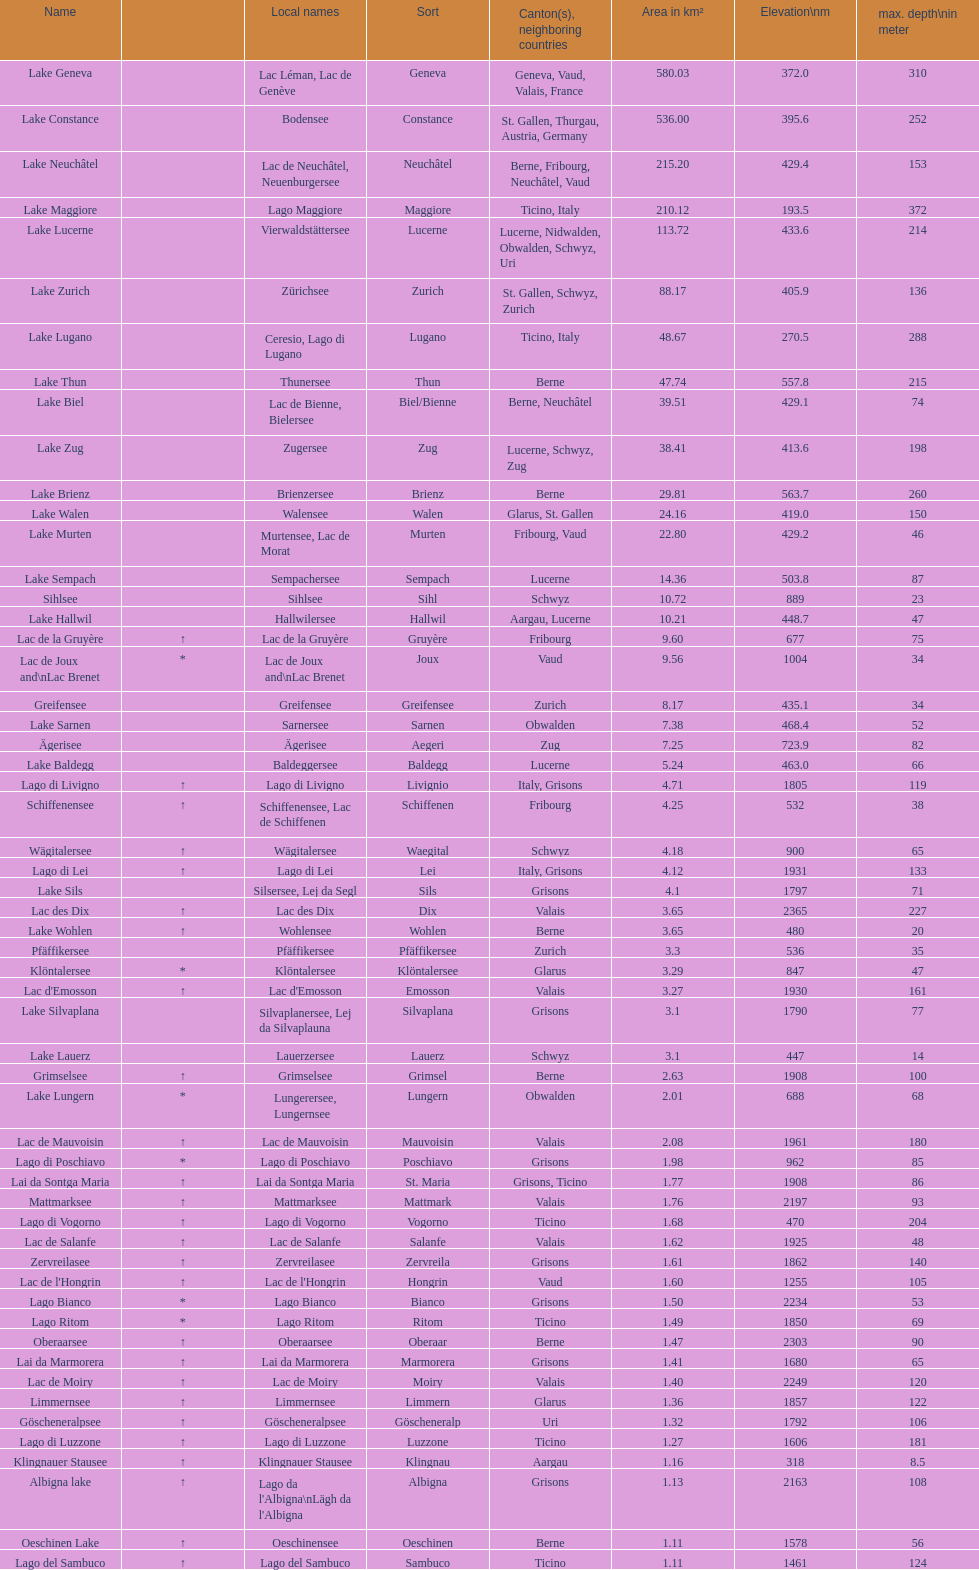Write the full table. {'header': ['Name', '', 'Local names', 'Sort', 'Canton(s), neighboring countries', 'Area in km²', 'Elevation\\nm', 'max. depth\\nin meter'], 'rows': [['Lake Geneva', '', 'Lac Léman, Lac de Genève', 'Geneva', 'Geneva, Vaud, Valais, France', '580.03', '372.0', '310'], ['Lake Constance', '', 'Bodensee', 'Constance', 'St. Gallen, Thurgau, Austria, Germany', '536.00', '395.6', '252'], ['Lake Neuchâtel', '', 'Lac de Neuchâtel, Neuenburgersee', 'Neuchâtel', 'Berne, Fribourg, Neuchâtel, Vaud', '215.20', '429.4', '153'], ['Lake Maggiore', '', 'Lago Maggiore', 'Maggiore', 'Ticino, Italy', '210.12', '193.5', '372'], ['Lake Lucerne', '', 'Vierwaldstättersee', 'Lucerne', 'Lucerne, Nidwalden, Obwalden, Schwyz, Uri', '113.72', '433.6', '214'], ['Lake Zurich', '', 'Zürichsee', 'Zurich', 'St. Gallen, Schwyz, Zurich', '88.17', '405.9', '136'], ['Lake Lugano', '', 'Ceresio, Lago di Lugano', 'Lugano', 'Ticino, Italy', '48.67', '270.5', '288'], ['Lake Thun', '', 'Thunersee', 'Thun', 'Berne', '47.74', '557.8', '215'], ['Lake Biel', '', 'Lac de Bienne, Bielersee', 'Biel/Bienne', 'Berne, Neuchâtel', '39.51', '429.1', '74'], ['Lake Zug', '', 'Zugersee', 'Zug', 'Lucerne, Schwyz, Zug', '38.41', '413.6', '198'], ['Lake Brienz', '', 'Brienzersee', 'Brienz', 'Berne', '29.81', '563.7', '260'], ['Lake Walen', '', 'Walensee', 'Walen', 'Glarus, St. Gallen', '24.16', '419.0', '150'], ['Lake Murten', '', 'Murtensee, Lac de Morat', 'Murten', 'Fribourg, Vaud', '22.80', '429.2', '46'], ['Lake Sempach', '', 'Sempachersee', 'Sempach', 'Lucerne', '14.36', '503.8', '87'], ['Sihlsee', '', 'Sihlsee', 'Sihl', 'Schwyz', '10.72', '889', '23'], ['Lake Hallwil', '', 'Hallwilersee', 'Hallwil', 'Aargau, Lucerne', '10.21', '448.7', '47'], ['Lac de la Gruyère', '↑', 'Lac de la Gruyère', 'Gruyère', 'Fribourg', '9.60', '677', '75'], ['Lac de Joux and\\nLac Brenet', '*', 'Lac de Joux and\\nLac Brenet', 'Joux', 'Vaud', '9.56', '1004', '34'], ['Greifensee', '', 'Greifensee', 'Greifensee', 'Zurich', '8.17', '435.1', '34'], ['Lake Sarnen', '', 'Sarnersee', 'Sarnen', 'Obwalden', '7.38', '468.4', '52'], ['Ägerisee', '', 'Ägerisee', 'Aegeri', 'Zug', '7.25', '723.9', '82'], ['Lake Baldegg', '', 'Baldeggersee', 'Baldegg', 'Lucerne', '5.24', '463.0', '66'], ['Lago di Livigno', '↑', 'Lago di Livigno', 'Livignio', 'Italy, Grisons', '4.71', '1805', '119'], ['Schiffenensee', '↑', 'Schiffenensee, Lac de Schiffenen', 'Schiffenen', 'Fribourg', '4.25', '532', '38'], ['Wägitalersee', '↑', 'Wägitalersee', 'Waegital', 'Schwyz', '4.18', '900', '65'], ['Lago di Lei', '↑', 'Lago di Lei', 'Lei', 'Italy, Grisons', '4.12', '1931', '133'], ['Lake Sils', '', 'Silsersee, Lej da Segl', 'Sils', 'Grisons', '4.1', '1797', '71'], ['Lac des Dix', '↑', 'Lac des Dix', 'Dix', 'Valais', '3.65', '2365', '227'], ['Lake Wohlen', '↑', 'Wohlensee', 'Wohlen', 'Berne', '3.65', '480', '20'], ['Pfäffikersee', '', 'Pfäffikersee', 'Pfäffikersee', 'Zurich', '3.3', '536', '35'], ['Klöntalersee', '*', 'Klöntalersee', 'Klöntalersee', 'Glarus', '3.29', '847', '47'], ["Lac d'Emosson", '↑', "Lac d'Emosson", 'Emosson', 'Valais', '3.27', '1930', '161'], ['Lake Silvaplana', '', 'Silvaplanersee, Lej da Silvaplauna', 'Silvaplana', 'Grisons', '3.1', '1790', '77'], ['Lake Lauerz', '', 'Lauerzersee', 'Lauerz', 'Schwyz', '3.1', '447', '14'], ['Grimselsee', '↑', 'Grimselsee', 'Grimsel', 'Berne', '2.63', '1908', '100'], ['Lake Lungern', '*', 'Lungerersee, Lungernsee', 'Lungern', 'Obwalden', '2.01', '688', '68'], ['Lac de Mauvoisin', '↑', 'Lac de Mauvoisin', 'Mauvoisin', 'Valais', '2.08', '1961', '180'], ['Lago di Poschiavo', '*', 'Lago di Poschiavo', 'Poschiavo', 'Grisons', '1.98', '962', '85'], ['Lai da Sontga Maria', '↑', 'Lai da Sontga Maria', 'St. Maria', 'Grisons, Ticino', '1.77', '1908', '86'], ['Mattmarksee', '↑', 'Mattmarksee', 'Mattmark', 'Valais', '1.76', '2197', '93'], ['Lago di Vogorno', '↑', 'Lago di Vogorno', 'Vogorno', 'Ticino', '1.68', '470', '204'], ['Lac de Salanfe', '↑', 'Lac de Salanfe', 'Salanfe', 'Valais', '1.62', '1925', '48'], ['Zervreilasee', '↑', 'Zervreilasee', 'Zervreila', 'Grisons', '1.61', '1862', '140'], ["Lac de l'Hongrin", '↑', "Lac de l'Hongrin", 'Hongrin', 'Vaud', '1.60', '1255', '105'], ['Lago Bianco', '*', 'Lago Bianco', 'Bianco', 'Grisons', '1.50', '2234', '53'], ['Lago Ritom', '*', 'Lago Ritom', 'Ritom', 'Ticino', '1.49', '1850', '69'], ['Oberaarsee', '↑', 'Oberaarsee', 'Oberaar', 'Berne', '1.47', '2303', '90'], ['Lai da Marmorera', '↑', 'Lai da Marmorera', 'Marmorera', 'Grisons', '1.41', '1680', '65'], ['Lac de Moiry', '↑', 'Lac de Moiry', 'Moiry', 'Valais', '1.40', '2249', '120'], ['Limmernsee', '↑', 'Limmernsee', 'Limmern', 'Glarus', '1.36', '1857', '122'], ['Göscheneralpsee', '↑', 'Göscheneralpsee', 'Göscheneralp', 'Uri', '1.32', '1792', '106'], ['Lago di Luzzone', '↑', 'Lago di Luzzone', 'Luzzone', 'Ticino', '1.27', '1606', '181'], ['Klingnauer Stausee', '↑', 'Klingnauer Stausee', 'Klingnau', 'Aargau', '1.16', '318', '8.5'], ['Albigna lake', '↑', "Lago da l'Albigna\\nLägh da l'Albigna", 'Albigna', 'Grisons', '1.13', '2163', '108'], ['Oeschinen Lake', '↑', 'Oeschinensee', 'Oeschinen', 'Berne', '1.11', '1578', '56'], ['Lago del Sambuco', '↑', 'Lago del Sambuco', 'Sambuco', 'Ticino', '1.11', '1461', '124']]} Which lake can be found at an elevation exceeding 193m? Lake Maggiore. 